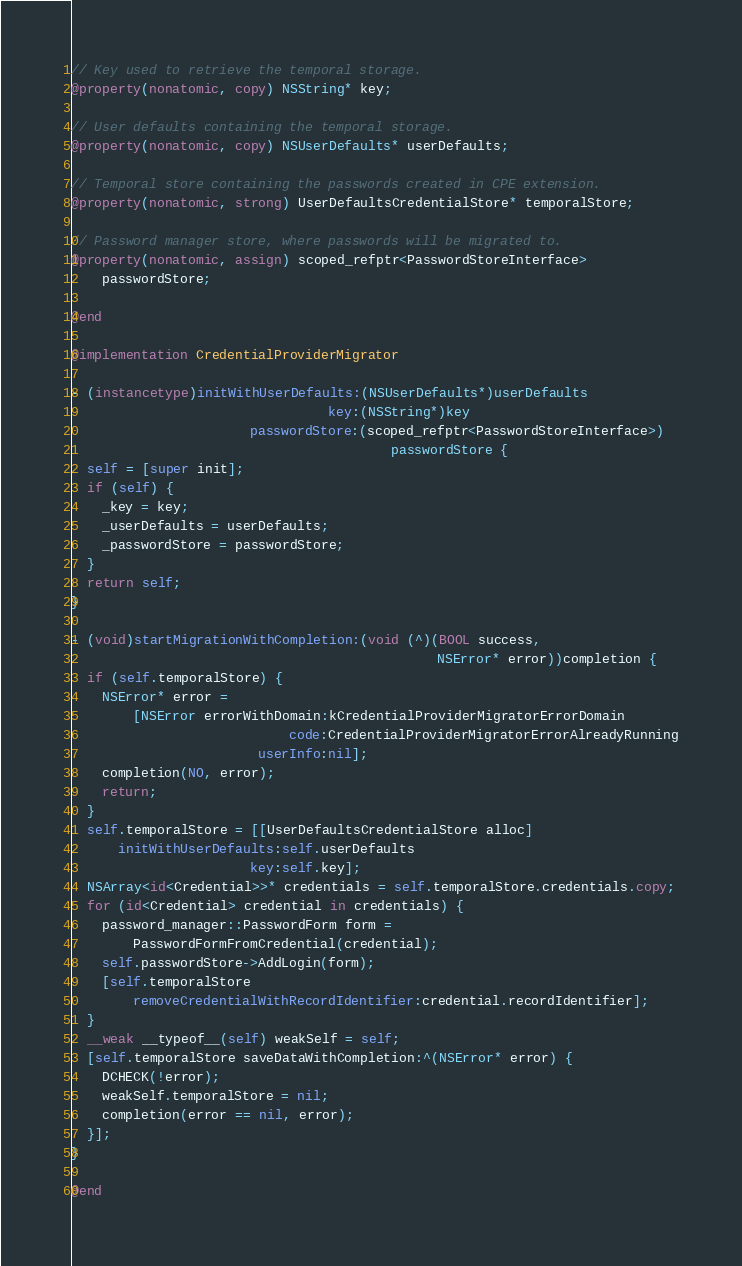<code> <loc_0><loc_0><loc_500><loc_500><_ObjectiveC_>
// Key used to retrieve the temporal storage.
@property(nonatomic, copy) NSString* key;

// User defaults containing the temporal storage.
@property(nonatomic, copy) NSUserDefaults* userDefaults;

// Temporal store containing the passwords created in CPE extension.
@property(nonatomic, strong) UserDefaultsCredentialStore* temporalStore;

// Password manager store, where passwords will be migrated to.
@property(nonatomic, assign) scoped_refptr<PasswordStoreInterface>
    passwordStore;

@end

@implementation CredentialProviderMigrator

- (instancetype)initWithUserDefaults:(NSUserDefaults*)userDefaults
                                 key:(NSString*)key
                       passwordStore:(scoped_refptr<PasswordStoreInterface>)
                                         passwordStore {
  self = [super init];
  if (self) {
    _key = key;
    _userDefaults = userDefaults;
    _passwordStore = passwordStore;
  }
  return self;
}

- (void)startMigrationWithCompletion:(void (^)(BOOL success,
                                               NSError* error))completion {
  if (self.temporalStore) {
    NSError* error =
        [NSError errorWithDomain:kCredentialProviderMigratorErrorDomain
                            code:CredentialProviderMigratorErrorAlreadyRunning
                        userInfo:nil];
    completion(NO, error);
    return;
  }
  self.temporalStore = [[UserDefaultsCredentialStore alloc]
      initWithUserDefaults:self.userDefaults
                       key:self.key];
  NSArray<id<Credential>>* credentials = self.temporalStore.credentials.copy;
  for (id<Credential> credential in credentials) {
    password_manager::PasswordForm form =
        PasswordFormFromCredential(credential);
    self.passwordStore->AddLogin(form);
    [self.temporalStore
        removeCredentialWithRecordIdentifier:credential.recordIdentifier];
  }
  __weak __typeof__(self) weakSelf = self;
  [self.temporalStore saveDataWithCompletion:^(NSError* error) {
    DCHECK(!error);
    weakSelf.temporalStore = nil;
    completion(error == nil, error);
  }];
}

@end
</code> 